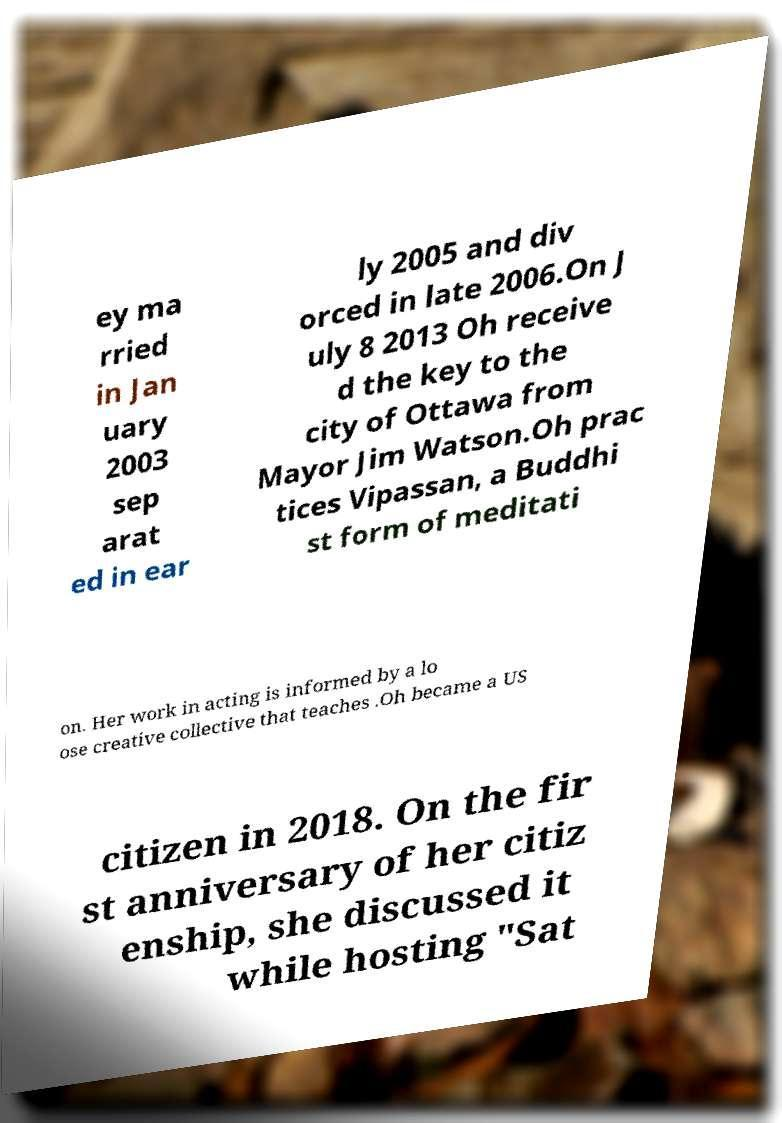Please identify and transcribe the text found in this image. ey ma rried in Jan uary 2003 sep arat ed in ear ly 2005 and div orced in late 2006.On J uly 8 2013 Oh receive d the key to the city of Ottawa from Mayor Jim Watson.Oh prac tices Vipassan, a Buddhi st form of meditati on. Her work in acting is informed by a lo ose creative collective that teaches .Oh became a US citizen in 2018. On the fir st anniversary of her citiz enship, she discussed it while hosting "Sat 